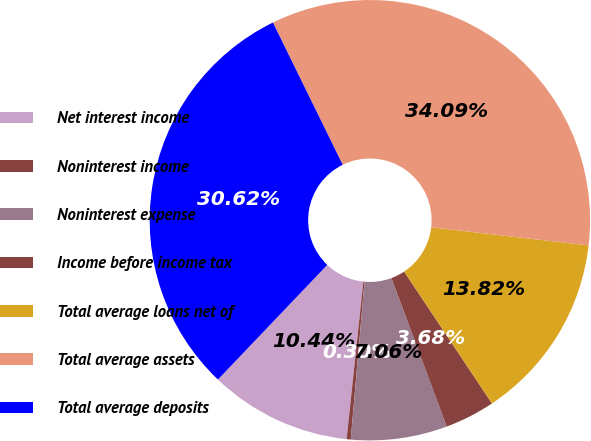Convert chart. <chart><loc_0><loc_0><loc_500><loc_500><pie_chart><fcel>Net interest income<fcel>Noninterest income<fcel>Noninterest expense<fcel>Income before income tax<fcel>Total average loans net of<fcel>Total average assets<fcel>Total average deposits<nl><fcel>10.44%<fcel>0.3%<fcel>7.06%<fcel>3.68%<fcel>13.82%<fcel>34.09%<fcel>30.62%<nl></chart> 